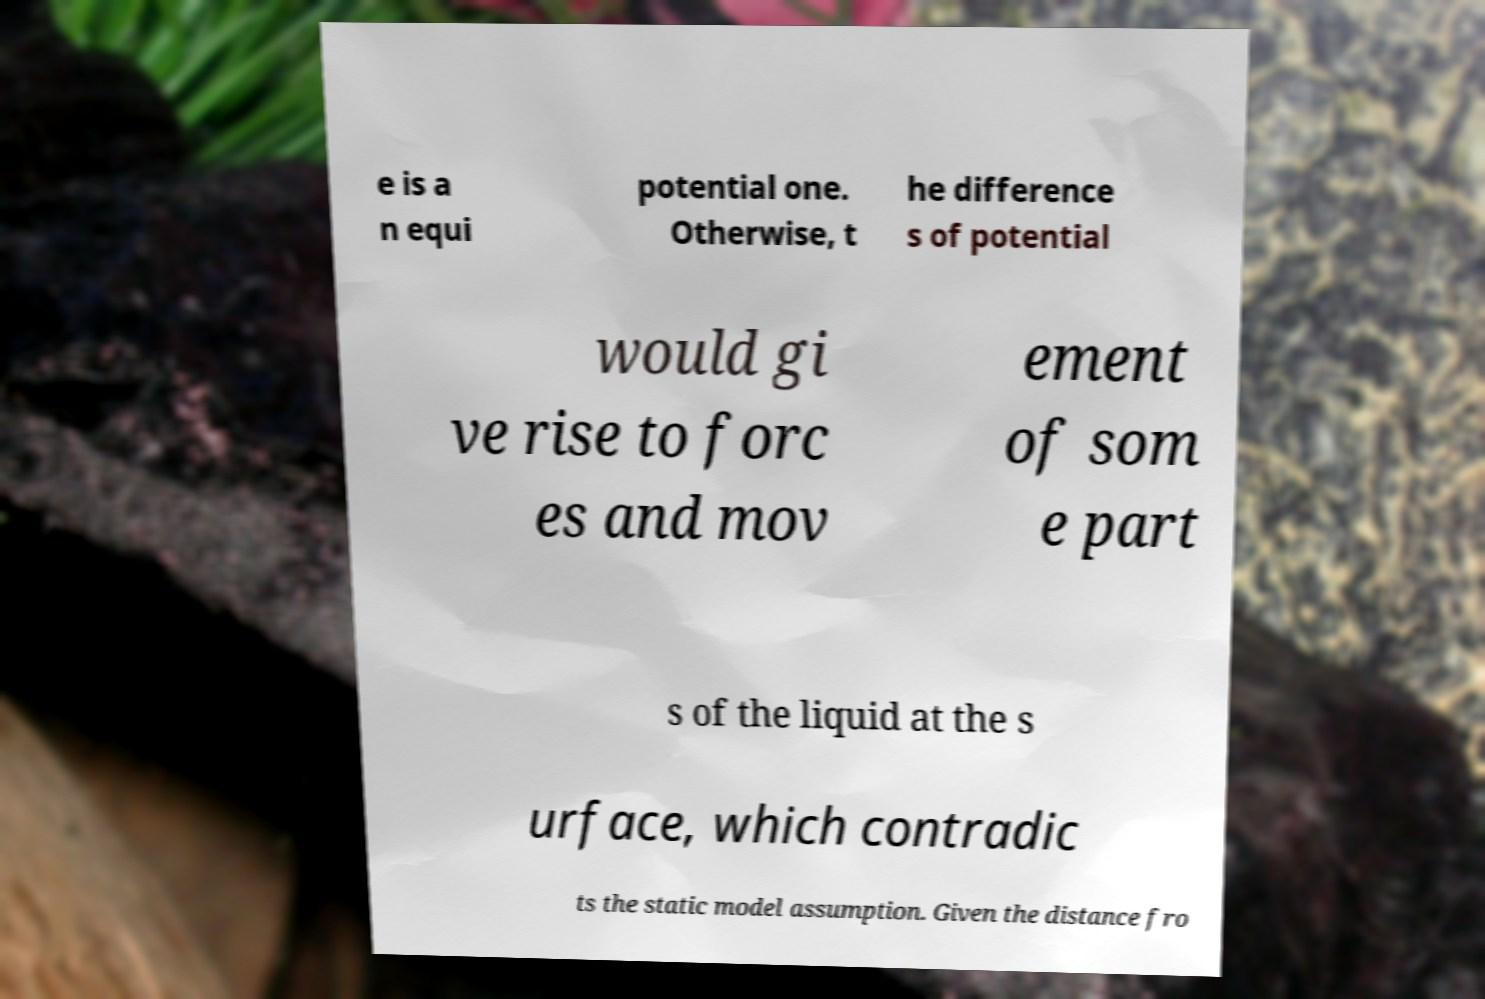Please read and relay the text visible in this image. What does it say? e is a n equi potential one. Otherwise, t he difference s of potential would gi ve rise to forc es and mov ement of som e part s of the liquid at the s urface, which contradic ts the static model assumption. Given the distance fro 